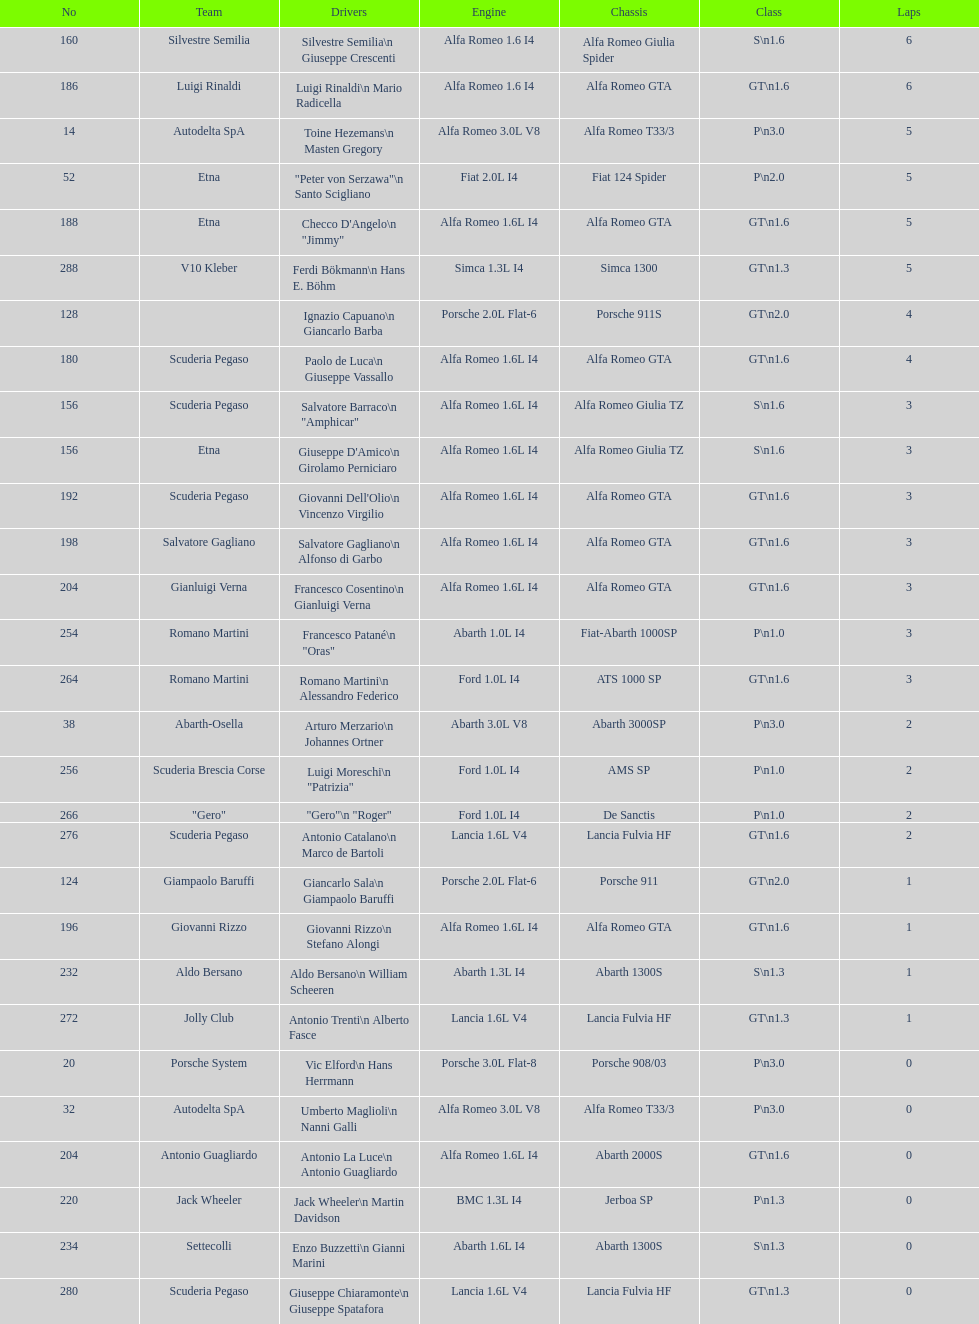How many drivers are from italy? 48. 